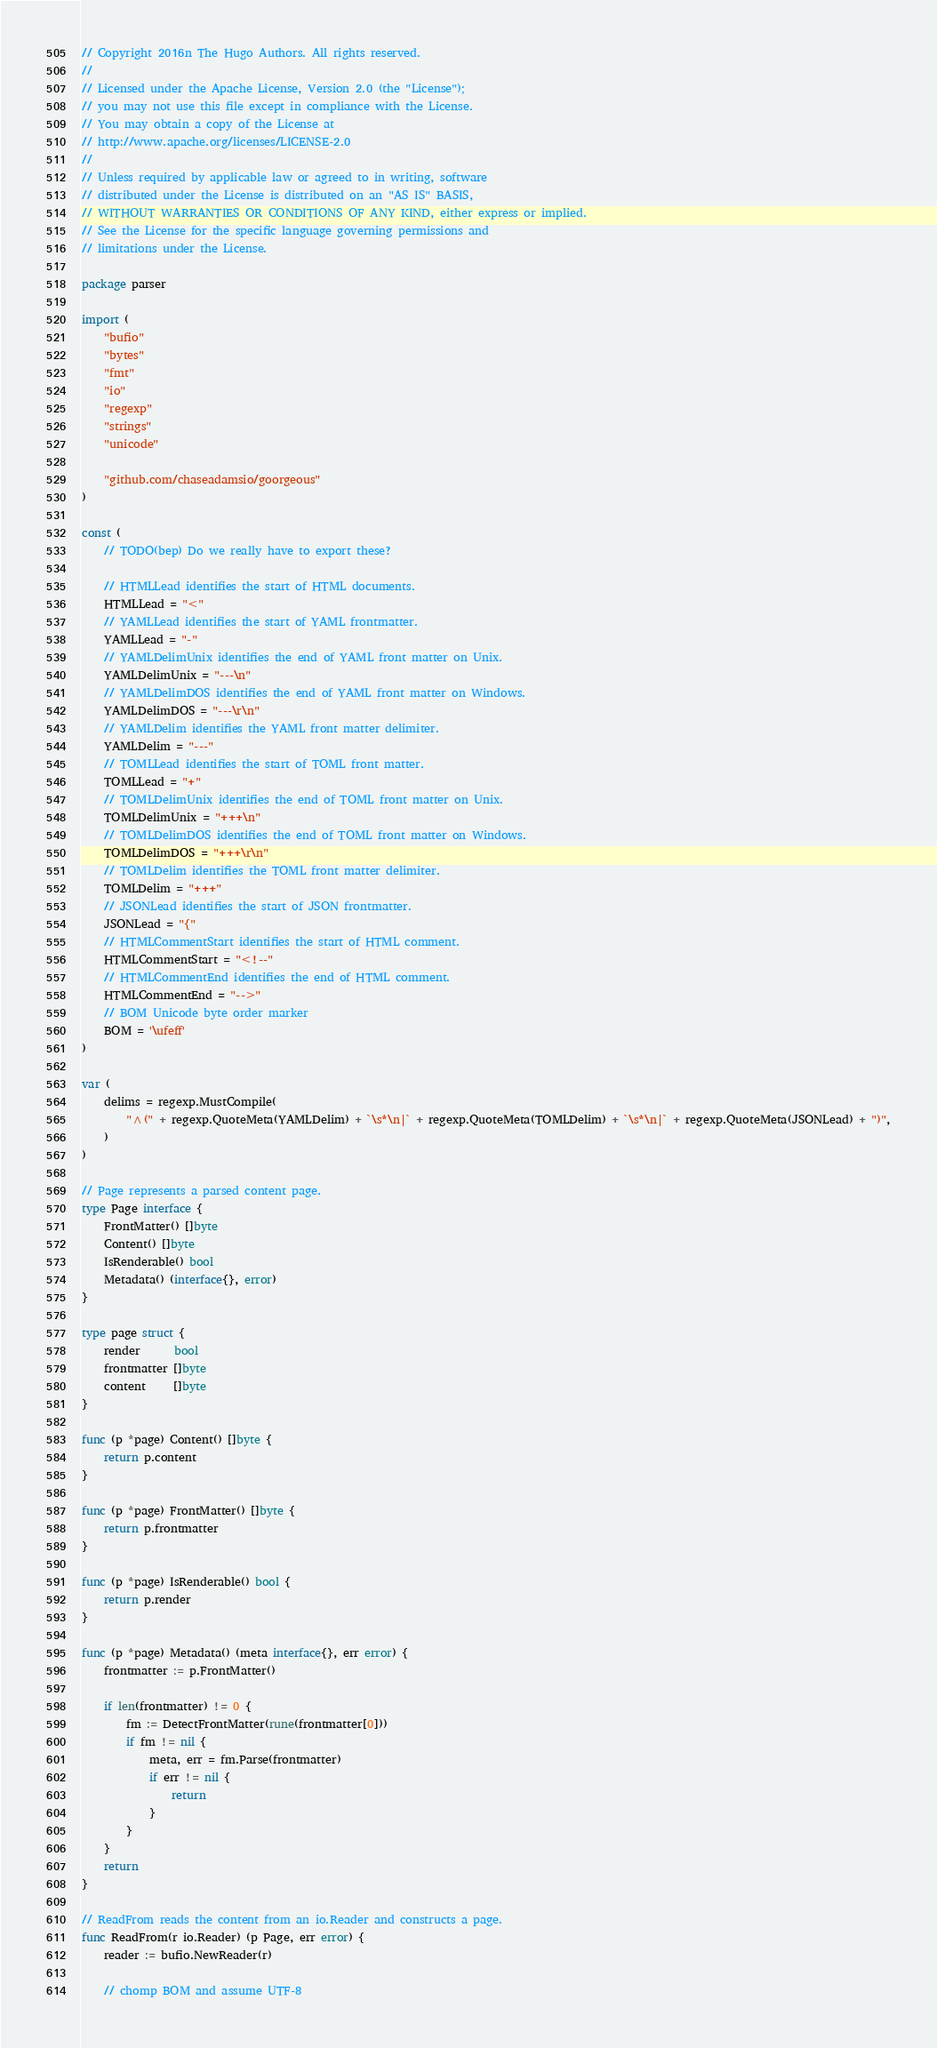Convert code to text. <code><loc_0><loc_0><loc_500><loc_500><_Go_>// Copyright 2016n The Hugo Authors. All rights reserved.
//
// Licensed under the Apache License, Version 2.0 (the "License");
// you may not use this file except in compliance with the License.
// You may obtain a copy of the License at
// http://www.apache.org/licenses/LICENSE-2.0
//
// Unless required by applicable law or agreed to in writing, software
// distributed under the License is distributed on an "AS IS" BASIS,
// WITHOUT WARRANTIES OR CONDITIONS OF ANY KIND, either express or implied.
// See the License for the specific language governing permissions and
// limitations under the License.

package parser

import (
	"bufio"
	"bytes"
	"fmt"
	"io"
	"regexp"
	"strings"
	"unicode"

	"github.com/chaseadamsio/goorgeous"
)

const (
	// TODO(bep) Do we really have to export these?

	// HTMLLead identifies the start of HTML documents.
	HTMLLead = "<"
	// YAMLLead identifies the start of YAML frontmatter.
	YAMLLead = "-"
	// YAMLDelimUnix identifies the end of YAML front matter on Unix.
	YAMLDelimUnix = "---\n"
	// YAMLDelimDOS identifies the end of YAML front matter on Windows.
	YAMLDelimDOS = "---\r\n"
	// YAMLDelim identifies the YAML front matter delimiter.
	YAMLDelim = "---"
	// TOMLLead identifies the start of TOML front matter.
	TOMLLead = "+"
	// TOMLDelimUnix identifies the end of TOML front matter on Unix.
	TOMLDelimUnix = "+++\n"
	// TOMLDelimDOS identifies the end of TOML front matter on Windows.
	TOMLDelimDOS = "+++\r\n"
	// TOMLDelim identifies the TOML front matter delimiter.
	TOMLDelim = "+++"
	// JSONLead identifies the start of JSON frontmatter.
	JSONLead = "{"
	// HTMLCommentStart identifies the start of HTML comment.
	HTMLCommentStart = "<!--"
	// HTMLCommentEnd identifies the end of HTML comment.
	HTMLCommentEnd = "-->"
	// BOM Unicode byte order marker
	BOM = '\ufeff'
)

var (
	delims = regexp.MustCompile(
		"^(" + regexp.QuoteMeta(YAMLDelim) + `\s*\n|` + regexp.QuoteMeta(TOMLDelim) + `\s*\n|` + regexp.QuoteMeta(JSONLead) + ")",
	)
)

// Page represents a parsed content page.
type Page interface {
	FrontMatter() []byte
	Content() []byte
	IsRenderable() bool
	Metadata() (interface{}, error)
}

type page struct {
	render      bool
	frontmatter []byte
	content     []byte
}

func (p *page) Content() []byte {
	return p.content
}

func (p *page) FrontMatter() []byte {
	return p.frontmatter
}

func (p *page) IsRenderable() bool {
	return p.render
}

func (p *page) Metadata() (meta interface{}, err error) {
	frontmatter := p.FrontMatter()

	if len(frontmatter) != 0 {
		fm := DetectFrontMatter(rune(frontmatter[0]))
		if fm != nil {
			meta, err = fm.Parse(frontmatter)
			if err != nil {
				return
			}
		}
	}
	return
}

// ReadFrom reads the content from an io.Reader and constructs a page.
func ReadFrom(r io.Reader) (p Page, err error) {
	reader := bufio.NewReader(r)

	// chomp BOM and assume UTF-8</code> 